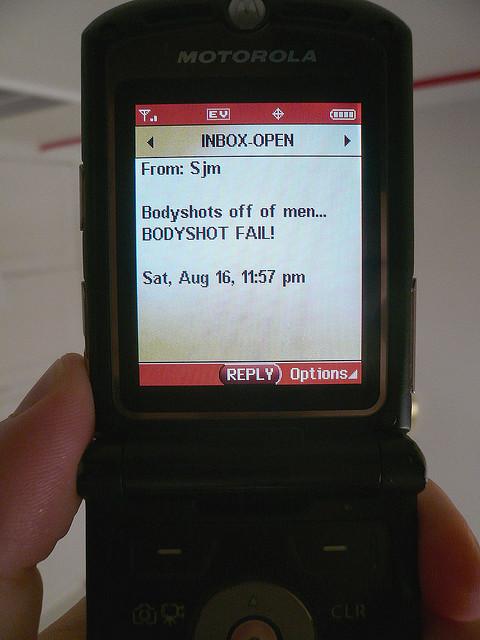What model of phone is this?
Keep it brief. Motorola. Has anything been typed into this device?
Short answer required. Yes. What fails in this picture?
Answer briefly. Body shot. What brand is the phone?
Write a very short answer. Motorola. What is the primary color of the phone?
Give a very brief answer. Black. Is there a map on the phone?
Short answer required. No. What time is listed?
Quick response, please. 11:57 pm. What brand of phone is it?
Concise answer only. Motorola. What is in the center of the screen?
Keep it brief. Inbox. Is this a flip phone?
Give a very brief answer. Yes. What name is on the phone?
Keep it brief. Sjm. 